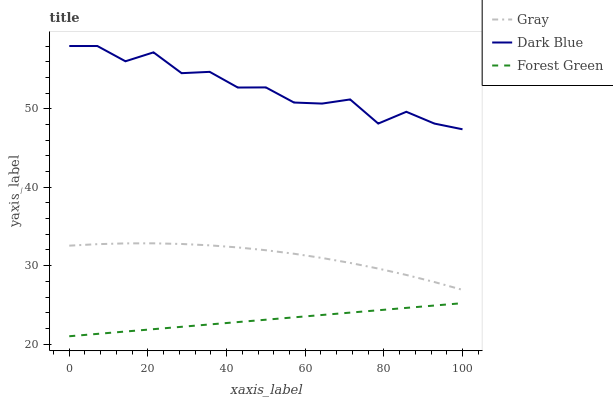Does Forest Green have the minimum area under the curve?
Answer yes or no. Yes. Does Dark Blue have the maximum area under the curve?
Answer yes or no. Yes. Does Dark Blue have the minimum area under the curve?
Answer yes or no. No. Does Forest Green have the maximum area under the curve?
Answer yes or no. No. Is Forest Green the smoothest?
Answer yes or no. Yes. Is Dark Blue the roughest?
Answer yes or no. Yes. Is Dark Blue the smoothest?
Answer yes or no. No. Is Forest Green the roughest?
Answer yes or no. No. Does Forest Green have the lowest value?
Answer yes or no. Yes. Does Dark Blue have the lowest value?
Answer yes or no. No. Does Dark Blue have the highest value?
Answer yes or no. Yes. Does Forest Green have the highest value?
Answer yes or no. No. Is Gray less than Dark Blue?
Answer yes or no. Yes. Is Gray greater than Forest Green?
Answer yes or no. Yes. Does Gray intersect Dark Blue?
Answer yes or no. No. 